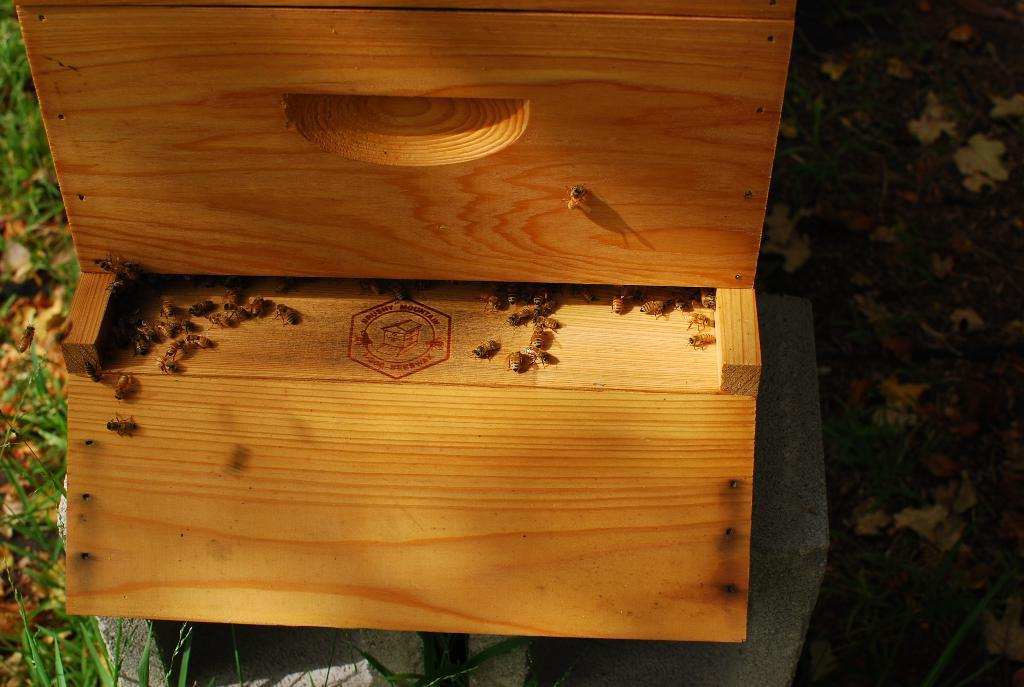What is the main object in the center of the image? There is a wooden box in the center of the image. What type of creatures can be seen in the image? There are honey bees in the image. What type of vegetation is visible at the bottom of the image? There is grass at the bottom of the image. What type of pets are visible in the image? There are no pets visible in the image; it features a wooden box and honey bees. What type of beef dish is being prepared in the image? There is no beef dish or any food preparation visible in the image. 